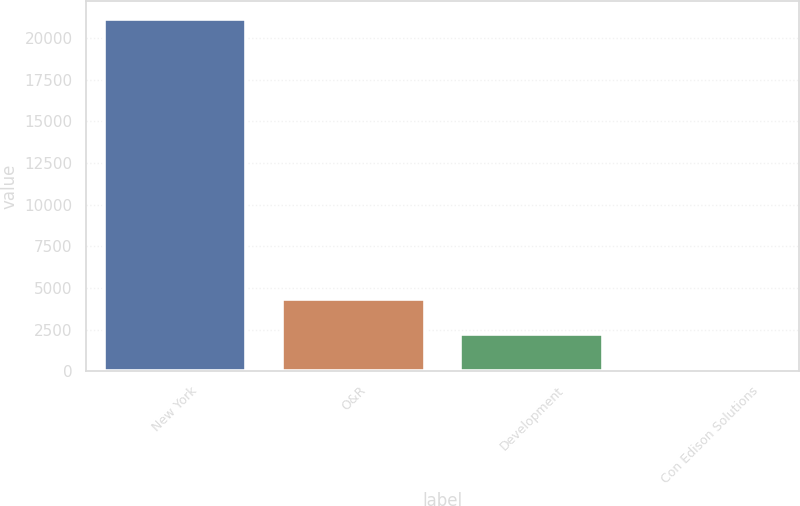<chart> <loc_0><loc_0><loc_500><loc_500><bar_chart><fcel>New York<fcel>O&R<fcel>Development<fcel>Con Edison Solutions<nl><fcel>21146<fcel>4340.4<fcel>2239.7<fcel>139<nl></chart> 